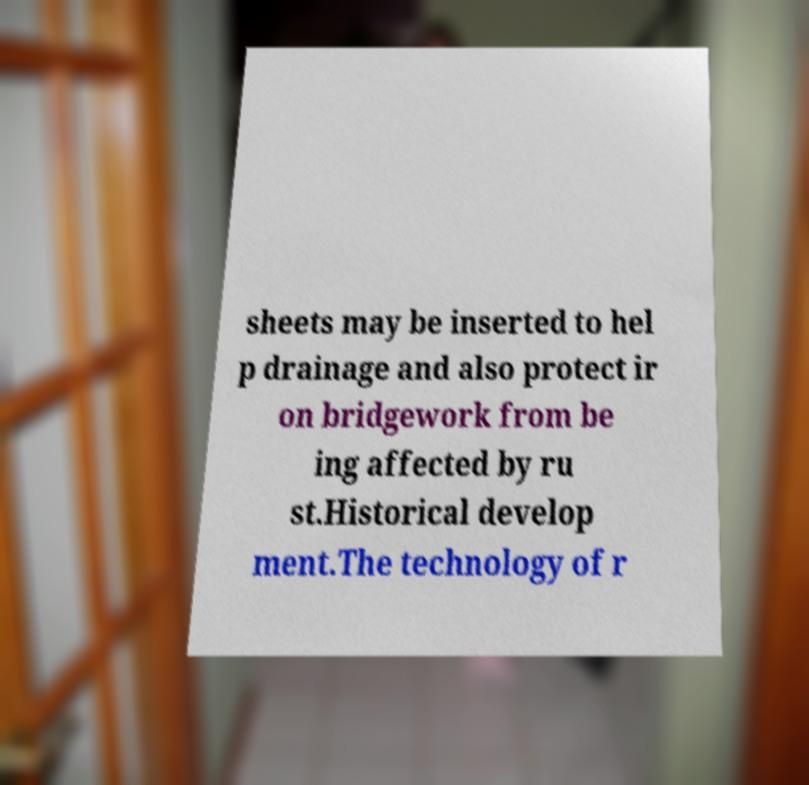What messages or text are displayed in this image? I need them in a readable, typed format. sheets may be inserted to hel p drainage and also protect ir on bridgework from be ing affected by ru st.Historical develop ment.The technology of r 